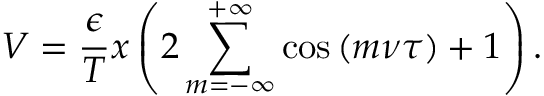Convert formula to latex. <formula><loc_0><loc_0><loc_500><loc_500>V = \frac { \epsilon } { T } x \left ( 2 \sum _ { m = - \infty } ^ { + \infty } \cos { ( m \nu \tau ) } + 1 \right ) .</formula> 